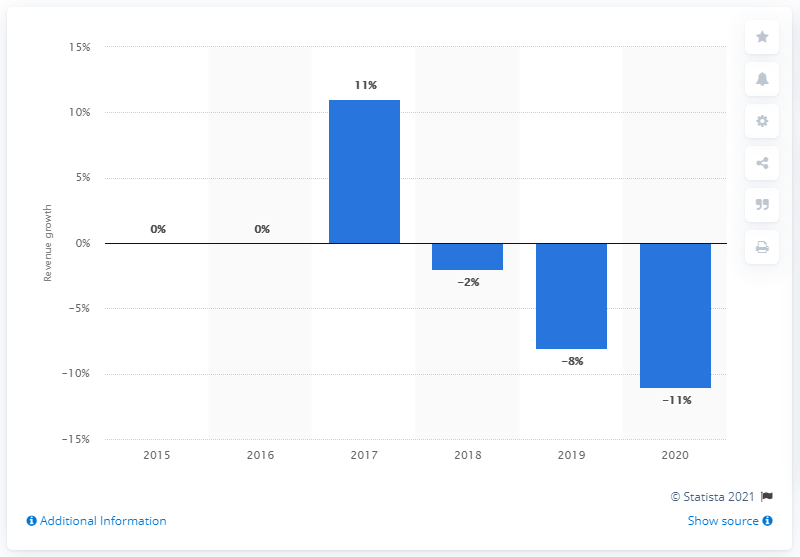Specify some key components in this picture. Pandora's revenue decreased significantly in 2020. 